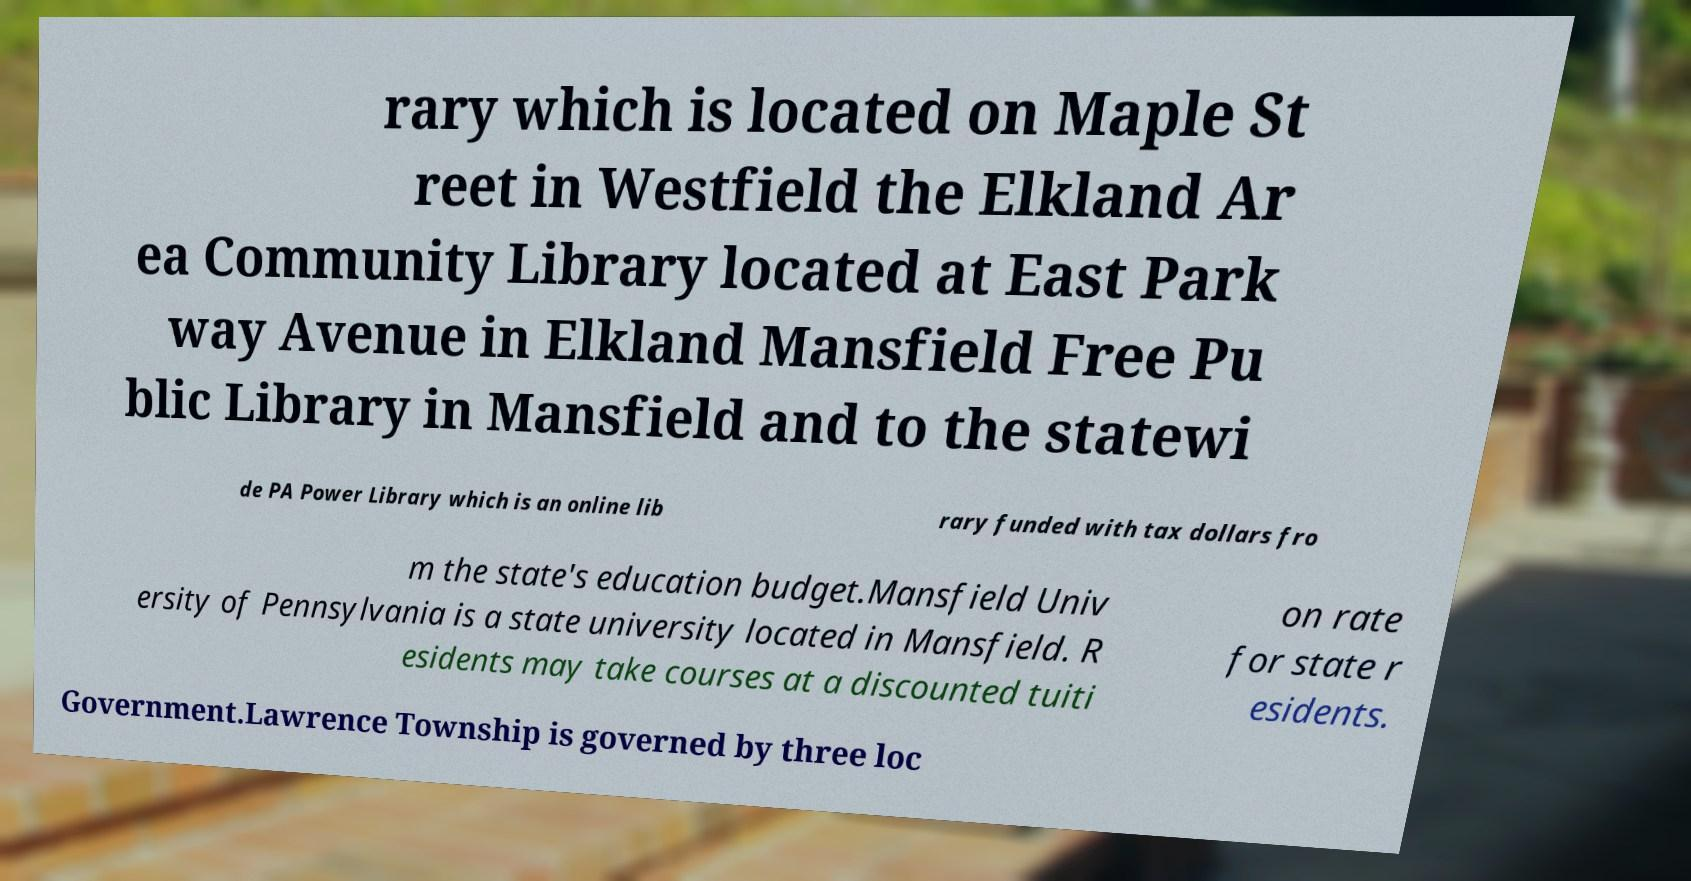Please read and relay the text visible in this image. What does it say? rary which is located on Maple St reet in Westfield the Elkland Ar ea Community Library located at East Park way Avenue in Elkland Mansfield Free Pu blic Library in Mansfield and to the statewi de PA Power Library which is an online lib rary funded with tax dollars fro m the state's education budget.Mansfield Univ ersity of Pennsylvania is a state university located in Mansfield. R esidents may take courses at a discounted tuiti on rate for state r esidents. Government.Lawrence Township is governed by three loc 